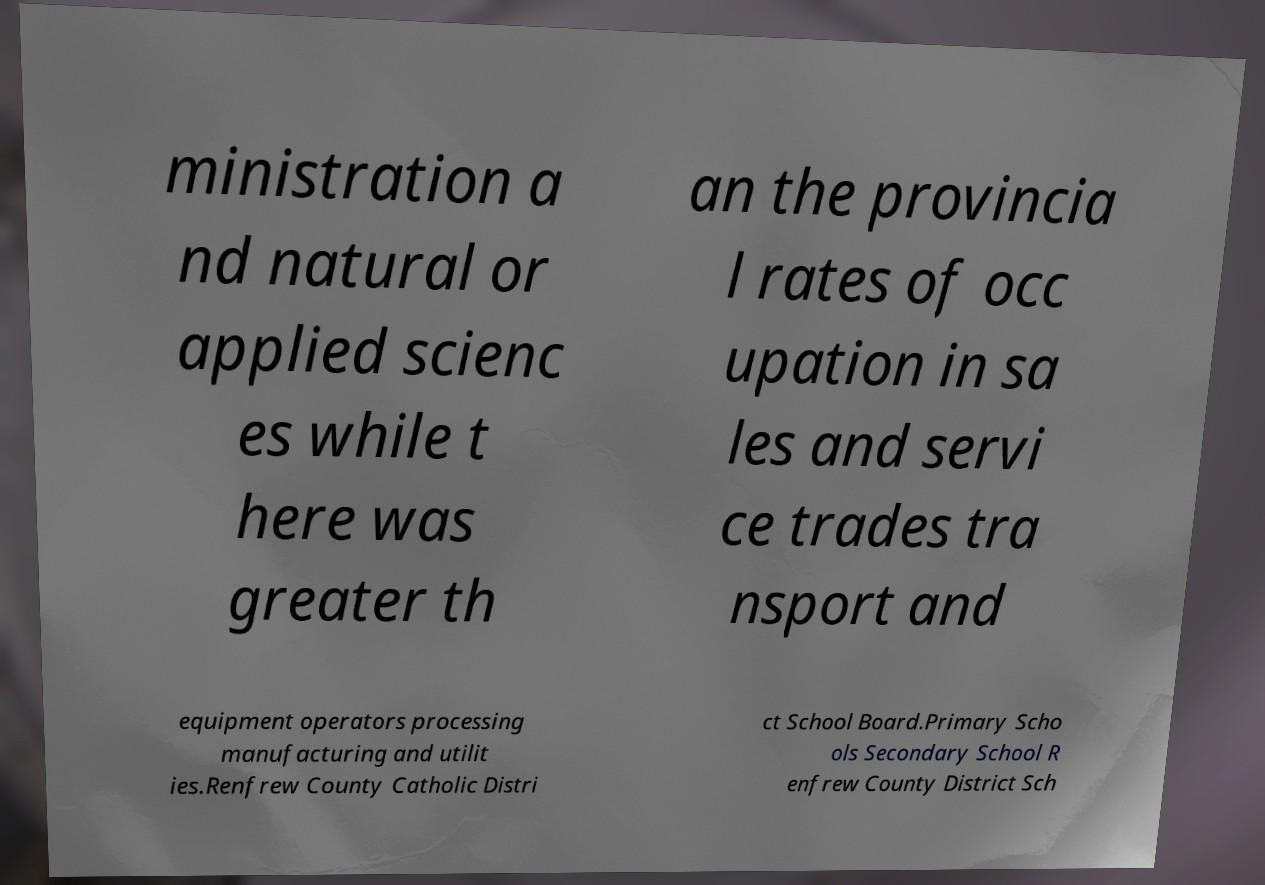Please identify and transcribe the text found in this image. ministration a nd natural or applied scienc es while t here was greater th an the provincia l rates of occ upation in sa les and servi ce trades tra nsport and equipment operators processing manufacturing and utilit ies.Renfrew County Catholic Distri ct School Board.Primary Scho ols Secondary School R enfrew County District Sch 